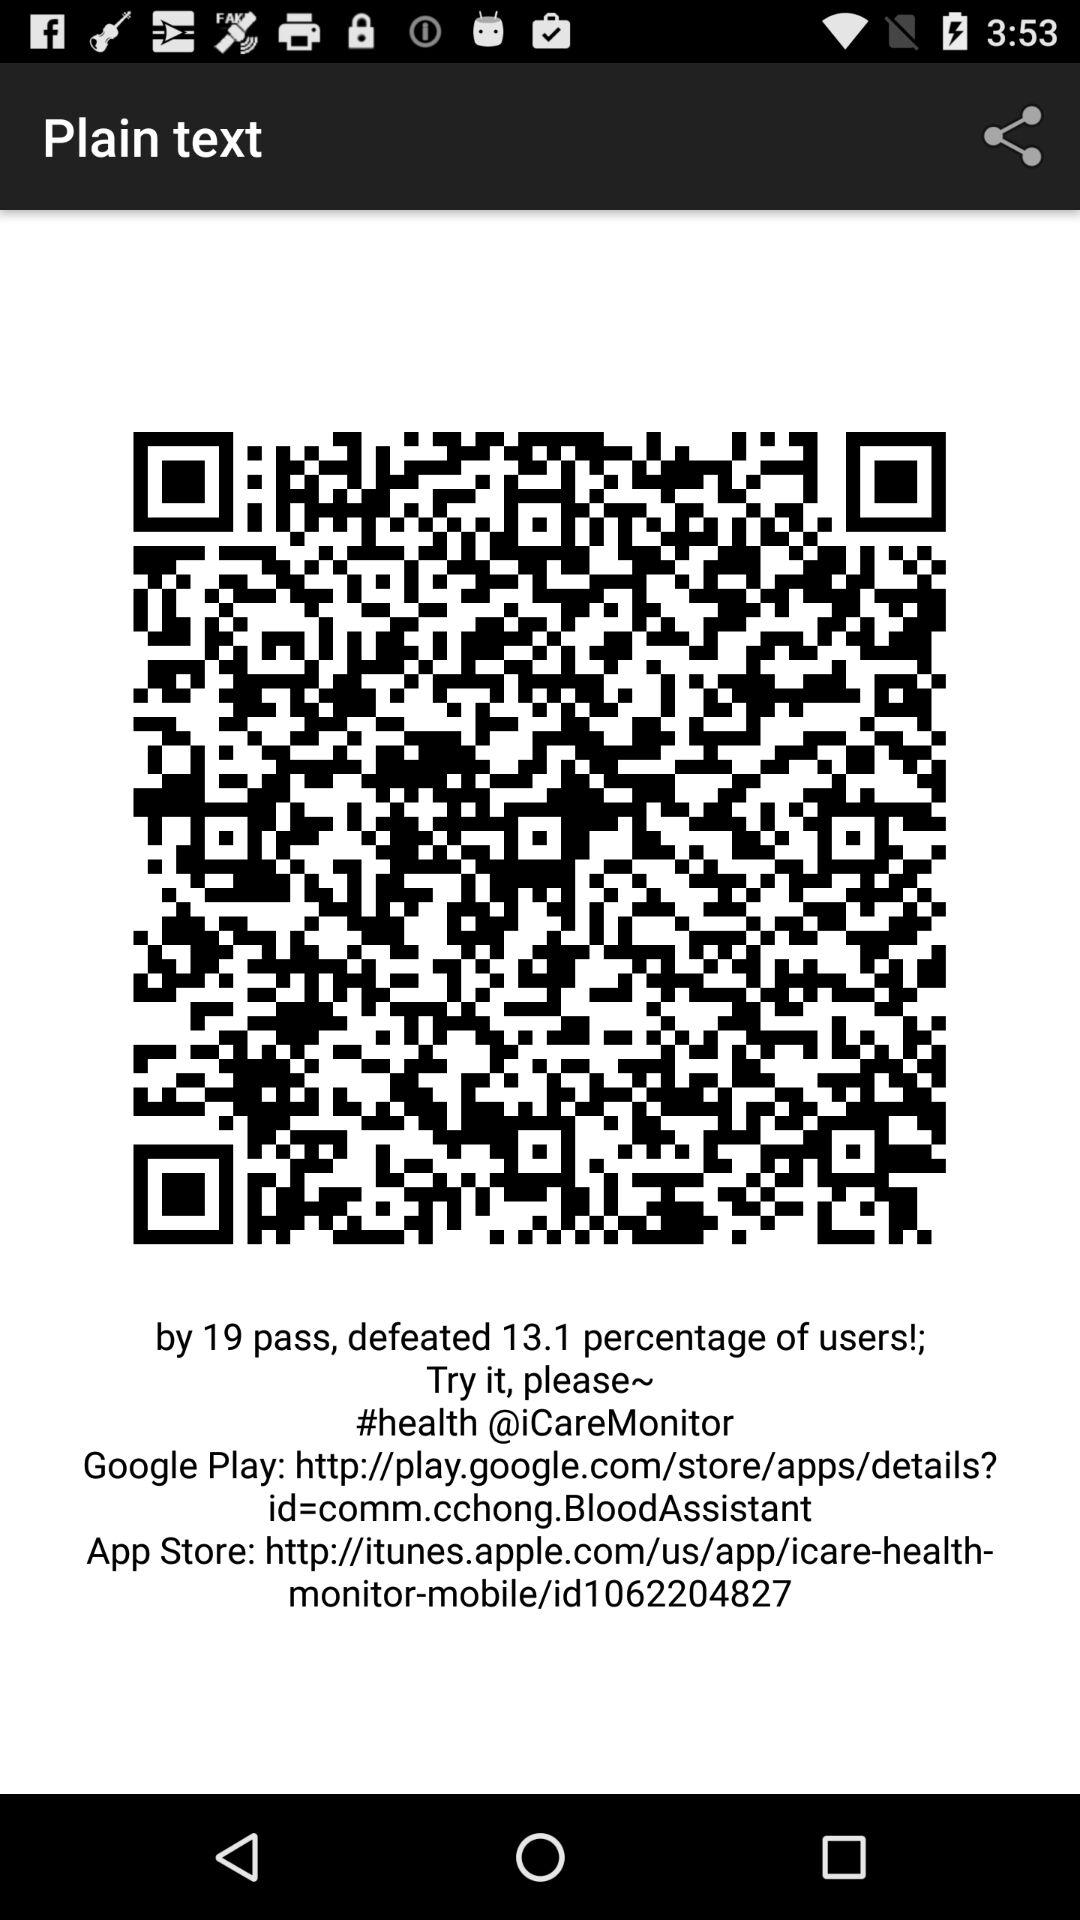What is the app store web link? The web link is http://itunes.apple.com/us/app/icare-health-monitor-mobile/id1062204827. 